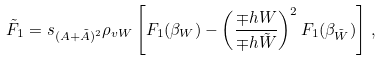<formula> <loc_0><loc_0><loc_500><loc_500>\tilde { F } _ { 1 } = s _ { ( A + \tilde { A } ) ^ { 2 } } \rho _ { v W } \left [ F _ { 1 } ( \beta _ { W } ) - \left ( \frac { \mp h { W } } { \mp h { \tilde { W } } } \right ) ^ { 2 } F _ { 1 } ( \beta _ { \tilde { W } } ) \right ] \, ,</formula> 